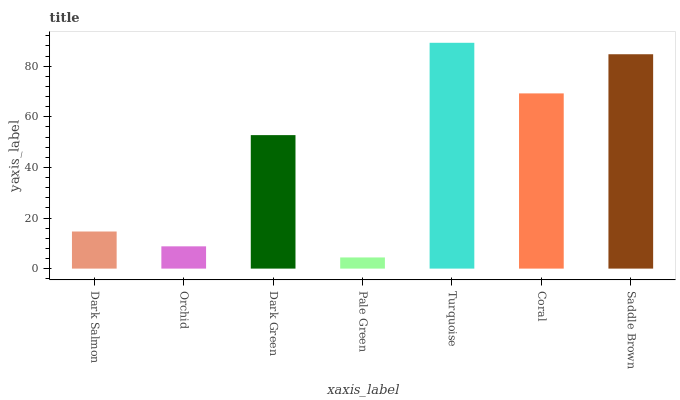Is Pale Green the minimum?
Answer yes or no. Yes. Is Turquoise the maximum?
Answer yes or no. Yes. Is Orchid the minimum?
Answer yes or no. No. Is Orchid the maximum?
Answer yes or no. No. Is Dark Salmon greater than Orchid?
Answer yes or no. Yes. Is Orchid less than Dark Salmon?
Answer yes or no. Yes. Is Orchid greater than Dark Salmon?
Answer yes or no. No. Is Dark Salmon less than Orchid?
Answer yes or no. No. Is Dark Green the high median?
Answer yes or no. Yes. Is Dark Green the low median?
Answer yes or no. Yes. Is Pale Green the high median?
Answer yes or no. No. Is Pale Green the low median?
Answer yes or no. No. 